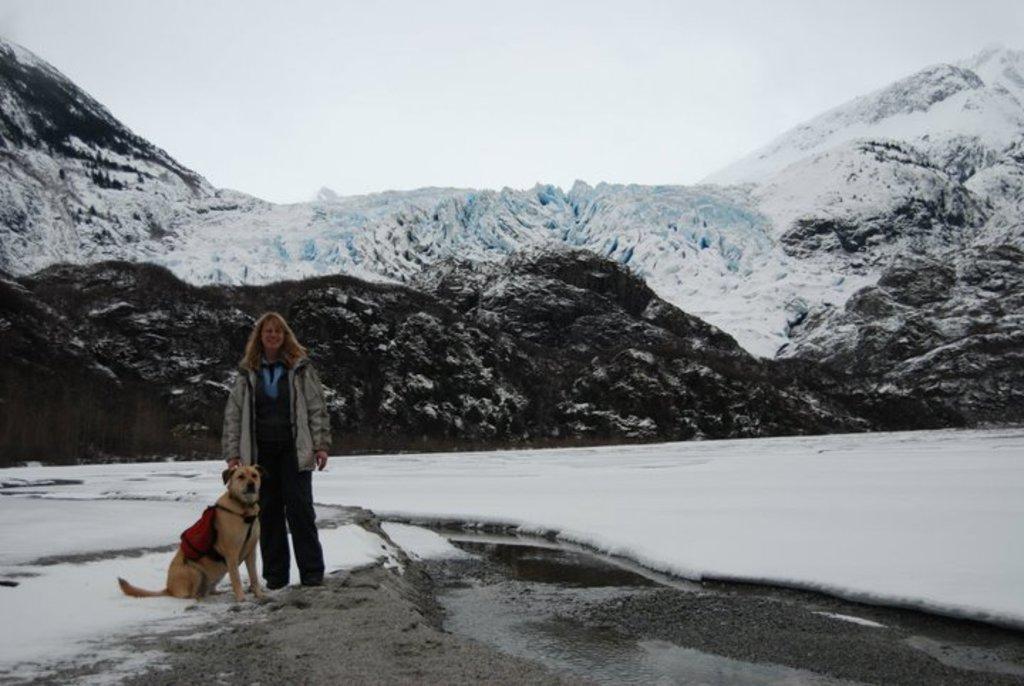Can you describe this image briefly? In the image we can see there is a woman standing and beside her there is a dog sitting on the ground. The ground is covered with snow, behind there are mountains which are covered with snow. There is a clear sky on the top. 